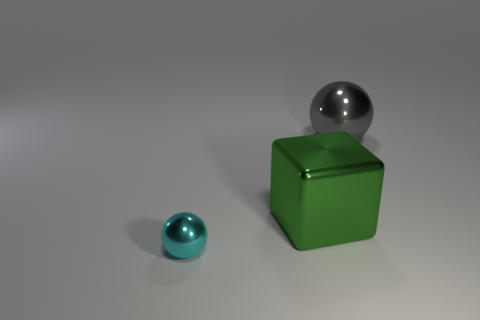What could be the potential size comparison between the gray sphere and the green cube? Based on their placement and perspective within the image, the gray sphere appears to be smaller than the green cube. However, without clear reference points for scale, the exact sizes are open to interpretation. 